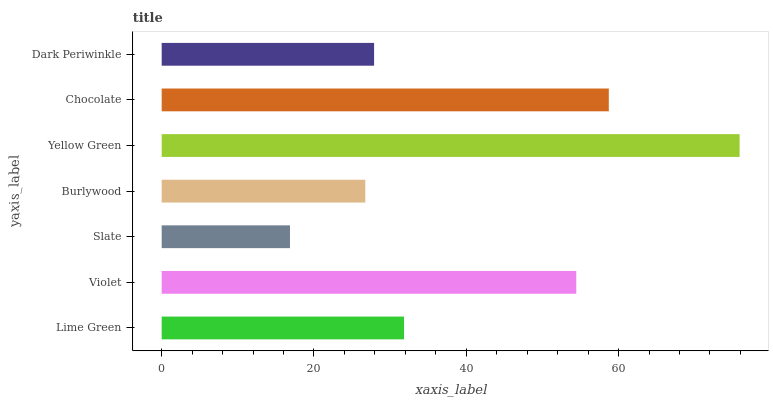Is Slate the minimum?
Answer yes or no. Yes. Is Yellow Green the maximum?
Answer yes or no. Yes. Is Violet the minimum?
Answer yes or no. No. Is Violet the maximum?
Answer yes or no. No. Is Violet greater than Lime Green?
Answer yes or no. Yes. Is Lime Green less than Violet?
Answer yes or no. Yes. Is Lime Green greater than Violet?
Answer yes or no. No. Is Violet less than Lime Green?
Answer yes or no. No. Is Lime Green the high median?
Answer yes or no. Yes. Is Lime Green the low median?
Answer yes or no. Yes. Is Yellow Green the high median?
Answer yes or no. No. Is Yellow Green the low median?
Answer yes or no. No. 